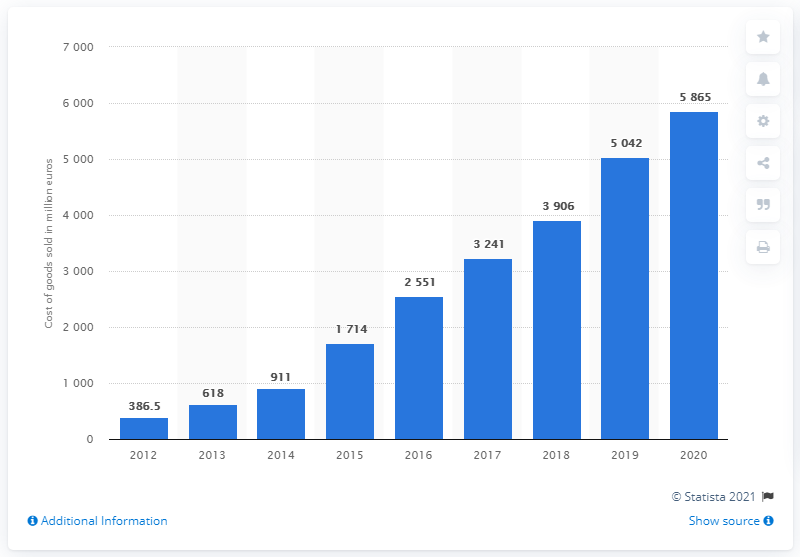Indicate a few pertinent items in this graphic. The sum of the highest and lowest values of the blue bar is 6251.5. Spotify's cost of sales in 2020 was approximately $58,650. The lowest value in the blue bar is 386.5. 